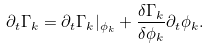<formula> <loc_0><loc_0><loc_500><loc_500>\partial _ { t } \Gamma _ { k } = \partial _ { t } \Gamma _ { k } | _ { \phi _ { k } } + \frac { \delta \Gamma _ { k } } { \delta \phi _ { k } } \partial _ { t } \phi _ { k } .</formula> 